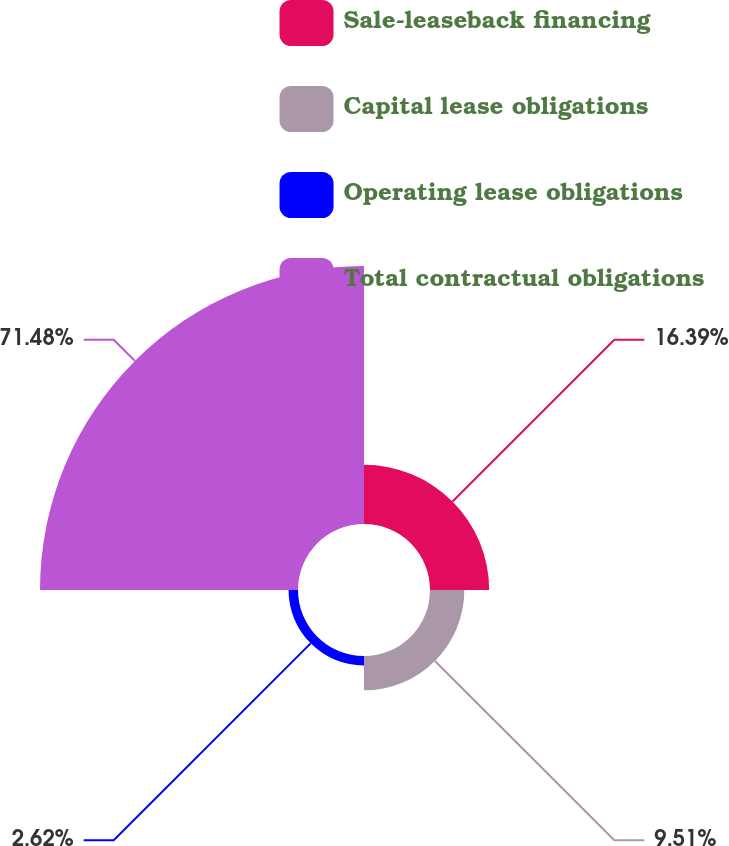Convert chart to OTSL. <chart><loc_0><loc_0><loc_500><loc_500><pie_chart><fcel>Sale-leaseback financing<fcel>Capital lease obligations<fcel>Operating lease obligations<fcel>Total contractual obligations<nl><fcel>16.39%<fcel>9.51%<fcel>2.62%<fcel>71.48%<nl></chart> 